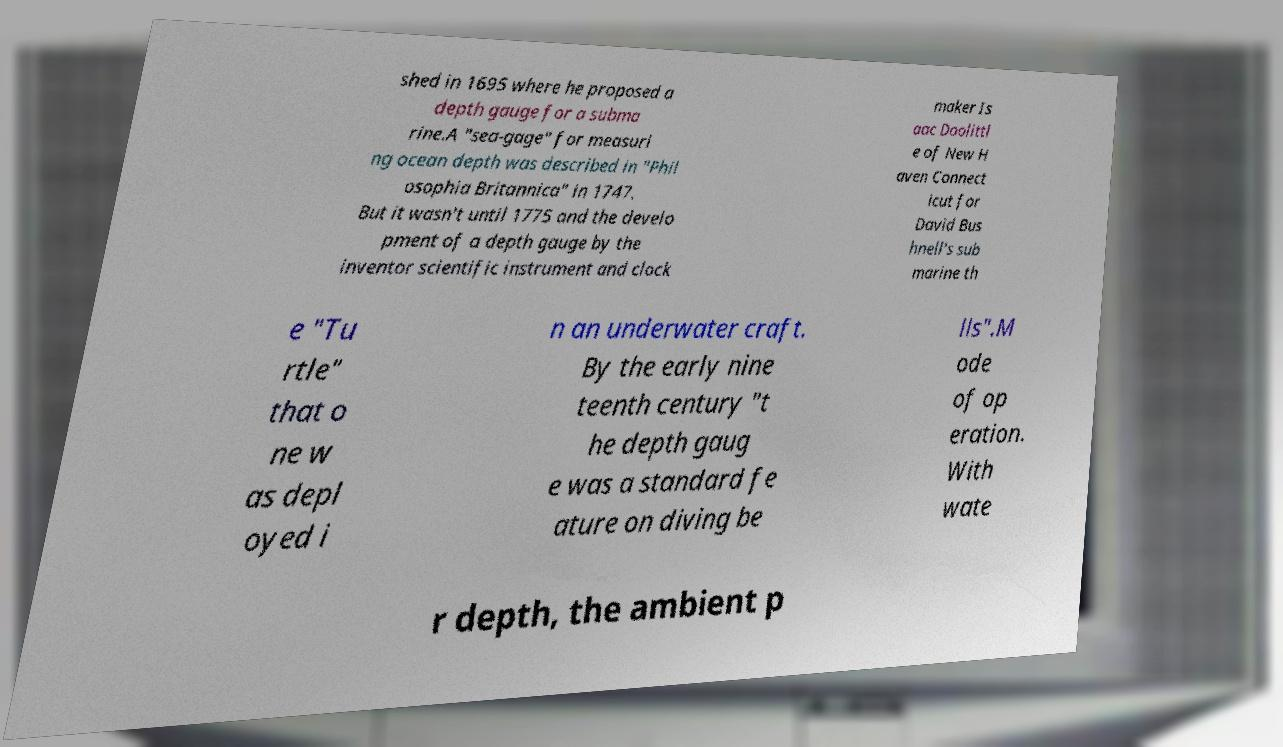Please identify and transcribe the text found in this image. shed in 1695 where he proposed a depth gauge for a subma rine.A "sea-gage" for measuri ng ocean depth was described in "Phil osophia Britannica" in 1747. But it wasn't until 1775 and the develo pment of a depth gauge by the inventor scientific instrument and clock maker Is aac Doolittl e of New H aven Connect icut for David Bus hnell's sub marine th e "Tu rtle" that o ne w as depl oyed i n an underwater craft. By the early nine teenth century "t he depth gaug e was a standard fe ature on diving be lls".M ode of op eration. With wate r depth, the ambient p 